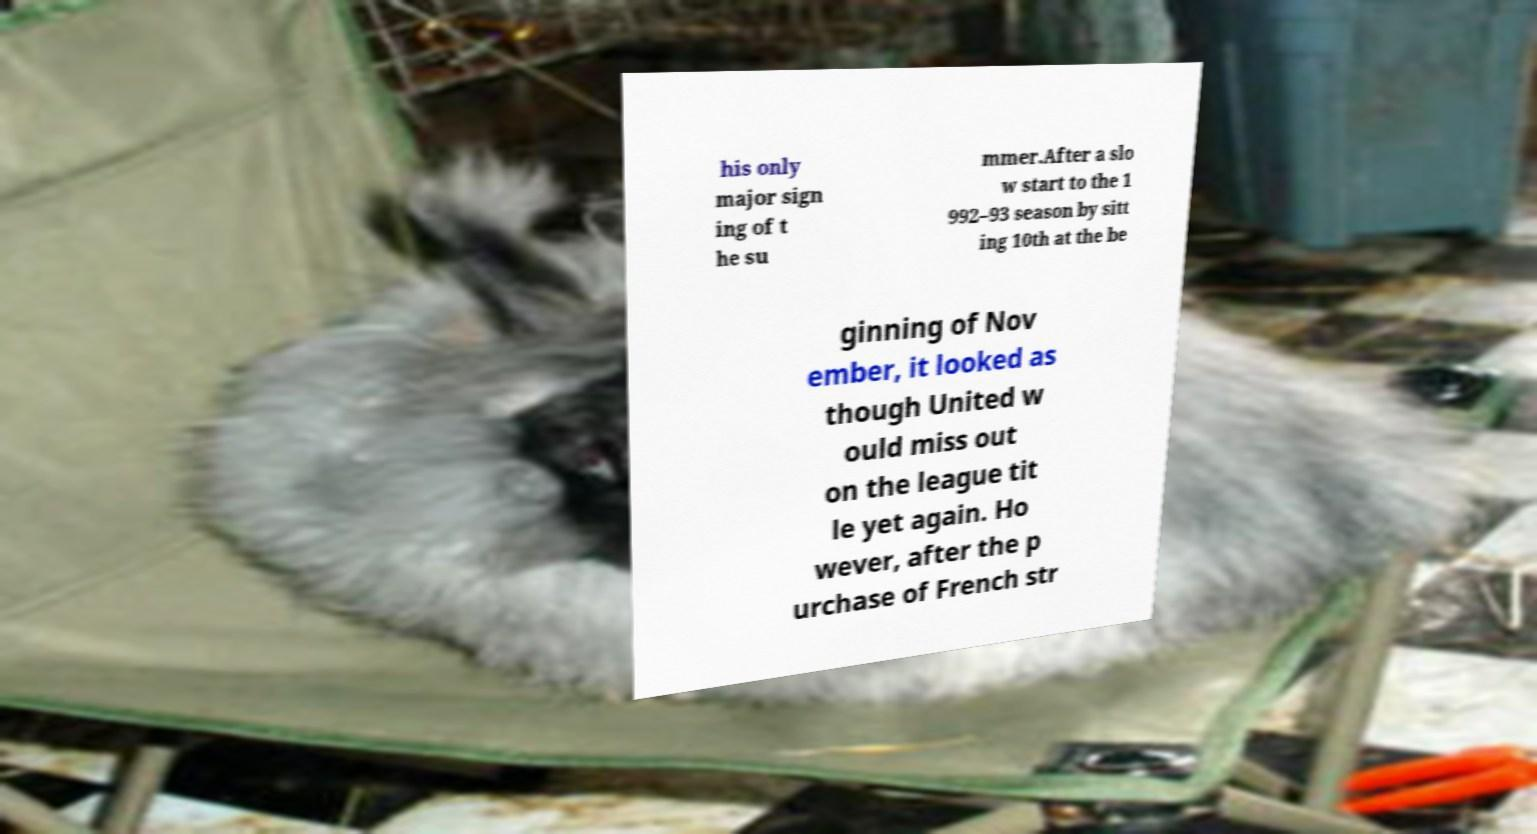Please identify and transcribe the text found in this image. his only major sign ing of t he su mmer.After a slo w start to the 1 992–93 season by sitt ing 10th at the be ginning of Nov ember, it looked as though United w ould miss out on the league tit le yet again. Ho wever, after the p urchase of French str 